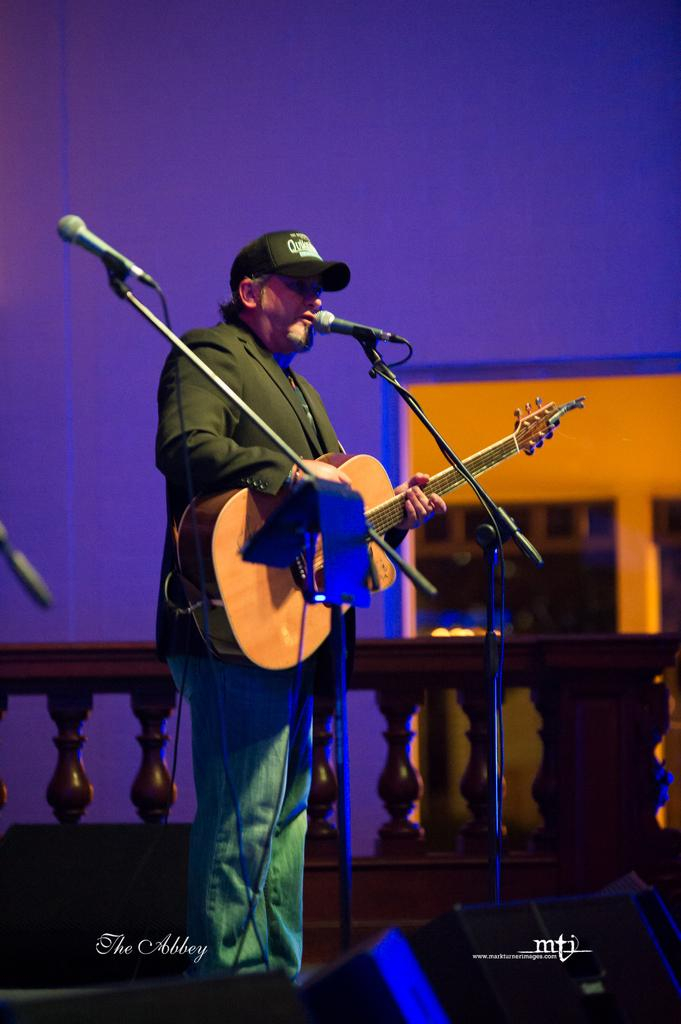What type of event is depicted in the image? The image is from a musical concert. What can be seen in the middle of the image? There are two microphones in the middle of the image. What instrument is the person holding? The person is holding a guitar. What is the person doing with the microphones? The person is singing. What type of clothing is the person wearing on their head? The person is wearing a cap. What type of clothing is the person wearing on their upper body? The person is wearing a blazer. Where is the cushion placed in the image? There is no cushion present in the image. Can you tell me how many volcanoes are visible in the image? There are no volcanoes visible in the image. 